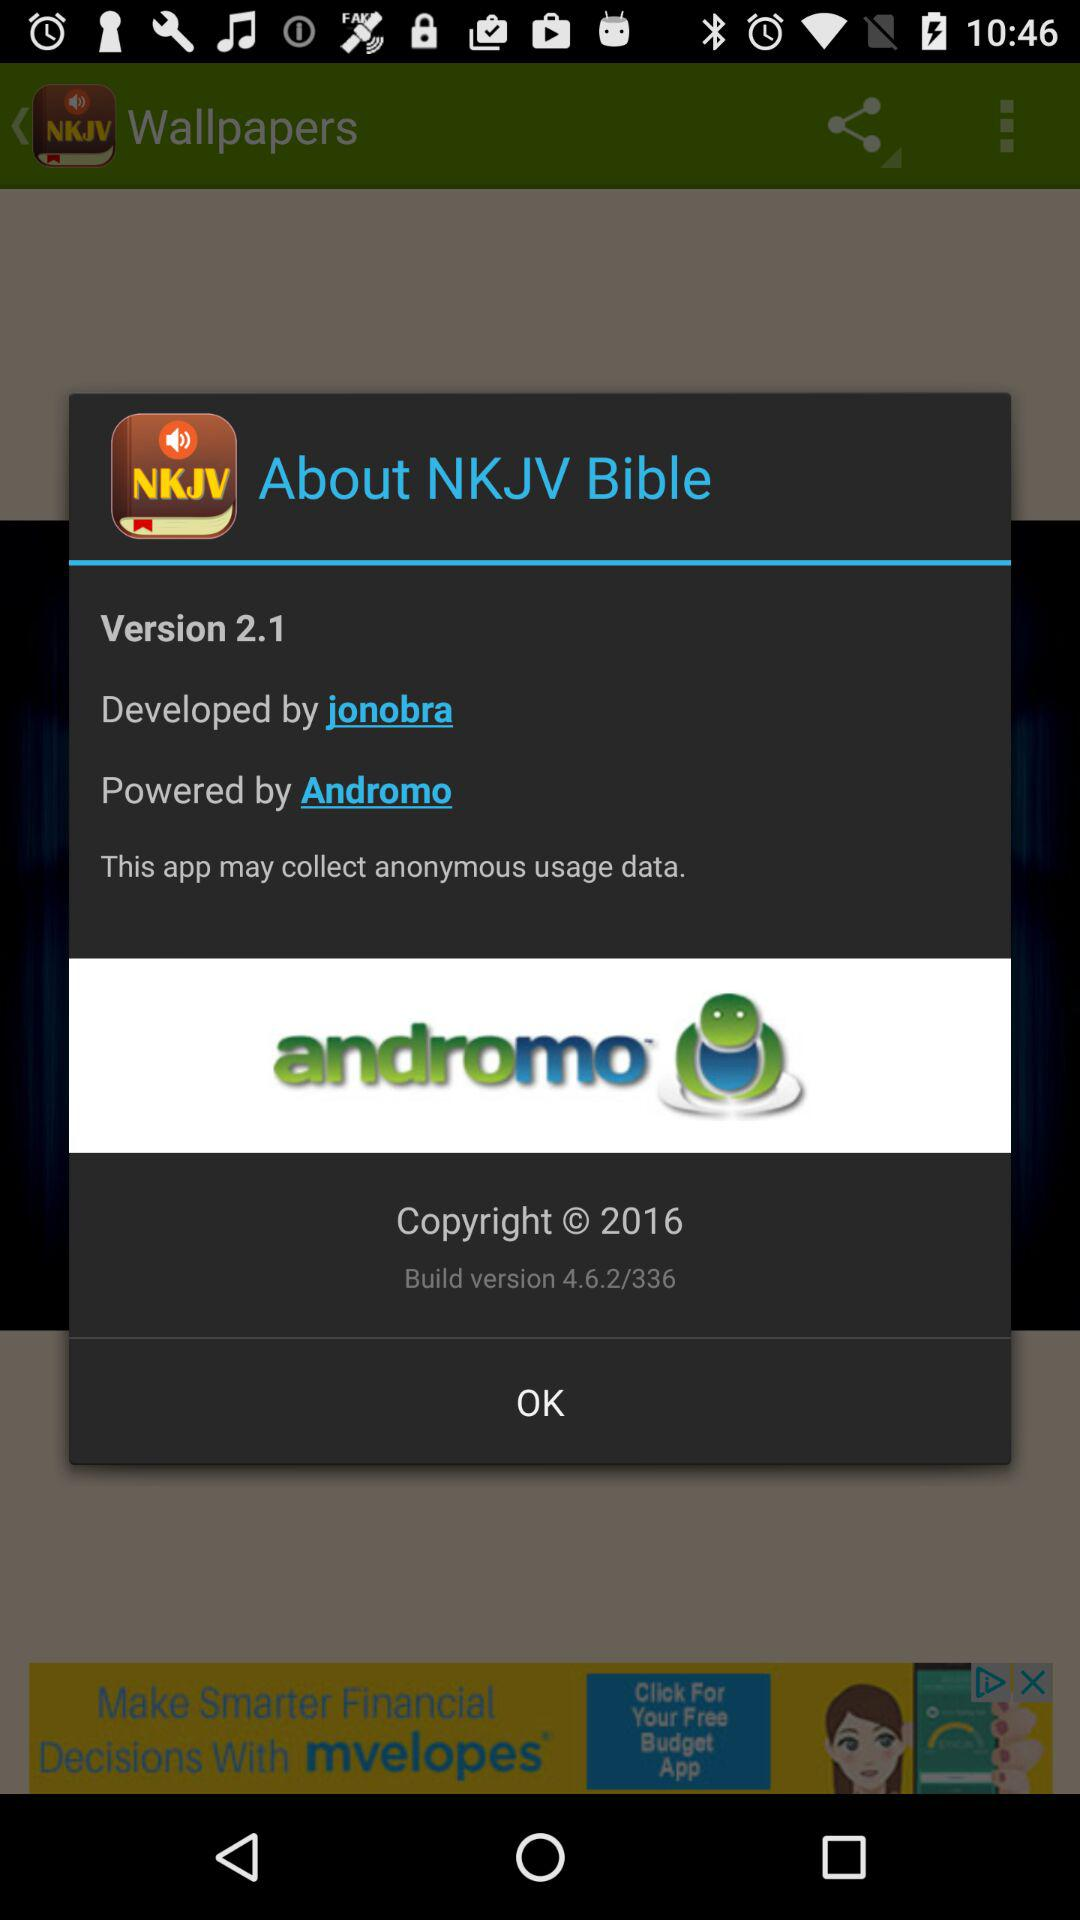What company powers the "NKJV Bible" application? The NKJV Bible application is powered by "Andromo". 